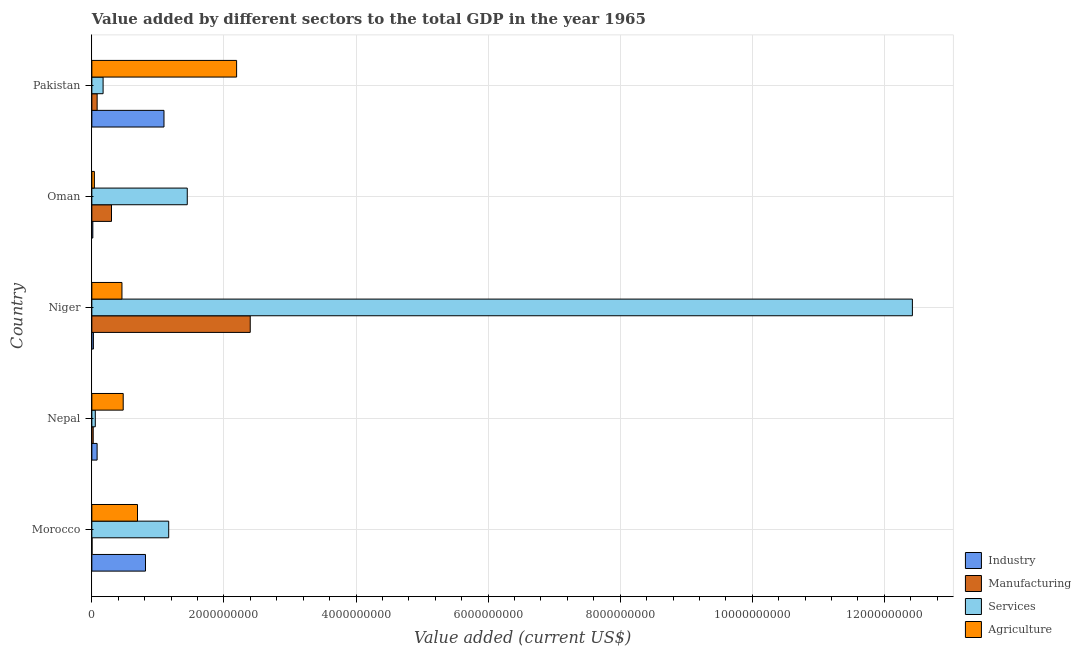How many different coloured bars are there?
Keep it short and to the point. 4. How many groups of bars are there?
Offer a terse response. 5. Are the number of bars per tick equal to the number of legend labels?
Ensure brevity in your answer.  Yes. How many bars are there on the 2nd tick from the top?
Provide a succinct answer. 4. How many bars are there on the 1st tick from the bottom?
Your answer should be very brief. 4. What is the label of the 3rd group of bars from the top?
Provide a succinct answer. Niger. In how many cases, is the number of bars for a given country not equal to the number of legend labels?
Your answer should be compact. 0. What is the value added by agricultural sector in Nepal?
Ensure brevity in your answer.  4.75e+08. Across all countries, what is the maximum value added by industrial sector?
Make the answer very short. 1.09e+09. Across all countries, what is the minimum value added by industrial sector?
Your answer should be compact. 1.48e+07. In which country was the value added by services sector maximum?
Keep it short and to the point. Niger. In which country was the value added by industrial sector minimum?
Make the answer very short. Oman. What is the total value added by services sector in the graph?
Your answer should be compact. 1.53e+1. What is the difference between the value added by services sector in Niger and that in Pakistan?
Ensure brevity in your answer.  1.23e+1. What is the difference between the value added by industrial sector in Morocco and the value added by agricultural sector in Oman?
Provide a short and direct response. 7.74e+08. What is the average value added by agricultural sector per country?
Provide a short and direct response. 7.70e+08. What is the difference between the value added by manufacturing sector and value added by services sector in Pakistan?
Offer a terse response. -9.02e+07. In how many countries, is the value added by industrial sector greater than 7200000000 US$?
Your answer should be very brief. 0. What is the ratio of the value added by industrial sector in Morocco to that in Nepal?
Offer a very short reply. 10.18. Is the value added by manufacturing sector in Oman less than that in Pakistan?
Your answer should be very brief. No. Is the difference between the value added by industrial sector in Nepal and Niger greater than the difference between the value added by manufacturing sector in Nepal and Niger?
Ensure brevity in your answer.  Yes. What is the difference between the highest and the second highest value added by manufacturing sector?
Your answer should be very brief. 2.10e+09. What is the difference between the highest and the lowest value added by services sector?
Make the answer very short. 1.24e+1. In how many countries, is the value added by agricultural sector greater than the average value added by agricultural sector taken over all countries?
Your answer should be very brief. 1. Is it the case that in every country, the sum of the value added by manufacturing sector and value added by industrial sector is greater than the sum of value added by services sector and value added by agricultural sector?
Offer a very short reply. No. What does the 4th bar from the top in Nepal represents?
Your answer should be very brief. Industry. What does the 4th bar from the bottom in Nepal represents?
Provide a succinct answer. Agriculture. How many bars are there?
Make the answer very short. 20. How many countries are there in the graph?
Provide a short and direct response. 5. What is the difference between two consecutive major ticks on the X-axis?
Provide a short and direct response. 2.00e+09. Are the values on the major ticks of X-axis written in scientific E-notation?
Make the answer very short. No. Does the graph contain grids?
Offer a terse response. Yes. How are the legend labels stacked?
Provide a short and direct response. Vertical. What is the title of the graph?
Offer a terse response. Value added by different sectors to the total GDP in the year 1965. Does "Interest Payments" appear as one of the legend labels in the graph?
Give a very brief answer. No. What is the label or title of the X-axis?
Give a very brief answer. Value added (current US$). What is the Value added (current US$) of Industry in Morocco?
Provide a short and direct response. 8.12e+08. What is the Value added (current US$) of Manufacturing in Morocco?
Ensure brevity in your answer.  3.06e+06. What is the Value added (current US$) in Services in Morocco?
Your answer should be very brief. 1.16e+09. What is the Value added (current US$) of Agriculture in Morocco?
Your answer should be very brief. 6.91e+08. What is the Value added (current US$) in Industry in Nepal?
Keep it short and to the point. 7.98e+07. What is the Value added (current US$) in Manufacturing in Nepal?
Give a very brief answer. 2.06e+07. What is the Value added (current US$) of Services in Nepal?
Your answer should be very brief. 5.22e+07. What is the Value added (current US$) of Agriculture in Nepal?
Provide a short and direct response. 4.75e+08. What is the Value added (current US$) of Industry in Niger?
Offer a terse response. 2.34e+07. What is the Value added (current US$) of Manufacturing in Niger?
Your response must be concise. 2.40e+09. What is the Value added (current US$) of Services in Niger?
Provide a short and direct response. 1.24e+1. What is the Value added (current US$) in Agriculture in Niger?
Ensure brevity in your answer.  4.56e+08. What is the Value added (current US$) of Industry in Oman?
Your answer should be very brief. 1.48e+07. What is the Value added (current US$) in Manufacturing in Oman?
Your answer should be very brief. 2.98e+08. What is the Value added (current US$) in Services in Oman?
Your response must be concise. 1.44e+09. What is the Value added (current US$) of Agriculture in Oman?
Your answer should be compact. 3.84e+07. What is the Value added (current US$) in Industry in Pakistan?
Offer a very short reply. 1.09e+09. What is the Value added (current US$) in Manufacturing in Pakistan?
Your answer should be very brief. 8.01e+07. What is the Value added (current US$) of Services in Pakistan?
Your answer should be compact. 1.70e+08. What is the Value added (current US$) in Agriculture in Pakistan?
Keep it short and to the point. 2.19e+09. Across all countries, what is the maximum Value added (current US$) of Industry?
Ensure brevity in your answer.  1.09e+09. Across all countries, what is the maximum Value added (current US$) of Manufacturing?
Make the answer very short. 2.40e+09. Across all countries, what is the maximum Value added (current US$) of Services?
Ensure brevity in your answer.  1.24e+1. Across all countries, what is the maximum Value added (current US$) in Agriculture?
Your response must be concise. 2.19e+09. Across all countries, what is the minimum Value added (current US$) in Industry?
Offer a terse response. 1.48e+07. Across all countries, what is the minimum Value added (current US$) of Manufacturing?
Give a very brief answer. 3.06e+06. Across all countries, what is the minimum Value added (current US$) of Services?
Give a very brief answer. 5.22e+07. Across all countries, what is the minimum Value added (current US$) of Agriculture?
Your answer should be very brief. 3.84e+07. What is the total Value added (current US$) in Industry in the graph?
Your answer should be compact. 2.02e+09. What is the total Value added (current US$) in Manufacturing in the graph?
Your response must be concise. 2.80e+09. What is the total Value added (current US$) in Services in the graph?
Ensure brevity in your answer.  1.53e+1. What is the total Value added (current US$) of Agriculture in the graph?
Provide a succinct answer. 3.85e+09. What is the difference between the Value added (current US$) of Industry in Morocco and that in Nepal?
Offer a very short reply. 7.32e+08. What is the difference between the Value added (current US$) in Manufacturing in Morocco and that in Nepal?
Keep it short and to the point. -1.76e+07. What is the difference between the Value added (current US$) of Services in Morocco and that in Nepal?
Your answer should be compact. 1.11e+09. What is the difference between the Value added (current US$) of Agriculture in Morocco and that in Nepal?
Make the answer very short. 2.16e+08. What is the difference between the Value added (current US$) in Industry in Morocco and that in Niger?
Your answer should be very brief. 7.89e+08. What is the difference between the Value added (current US$) of Manufacturing in Morocco and that in Niger?
Make the answer very short. -2.40e+09. What is the difference between the Value added (current US$) in Services in Morocco and that in Niger?
Give a very brief answer. -1.13e+1. What is the difference between the Value added (current US$) of Agriculture in Morocco and that in Niger?
Your answer should be very brief. 2.35e+08. What is the difference between the Value added (current US$) in Industry in Morocco and that in Oman?
Provide a succinct answer. 7.97e+08. What is the difference between the Value added (current US$) of Manufacturing in Morocco and that in Oman?
Provide a short and direct response. -2.95e+08. What is the difference between the Value added (current US$) in Services in Morocco and that in Oman?
Your answer should be compact. -2.81e+08. What is the difference between the Value added (current US$) of Agriculture in Morocco and that in Oman?
Offer a very short reply. 6.53e+08. What is the difference between the Value added (current US$) in Industry in Morocco and that in Pakistan?
Keep it short and to the point. -2.80e+08. What is the difference between the Value added (current US$) in Manufacturing in Morocco and that in Pakistan?
Give a very brief answer. -7.71e+07. What is the difference between the Value added (current US$) of Services in Morocco and that in Pakistan?
Ensure brevity in your answer.  9.93e+08. What is the difference between the Value added (current US$) in Agriculture in Morocco and that in Pakistan?
Offer a terse response. -1.50e+09. What is the difference between the Value added (current US$) of Industry in Nepal and that in Niger?
Your response must be concise. 5.64e+07. What is the difference between the Value added (current US$) of Manufacturing in Nepal and that in Niger?
Provide a short and direct response. -2.38e+09. What is the difference between the Value added (current US$) in Services in Nepal and that in Niger?
Your answer should be compact. -1.24e+1. What is the difference between the Value added (current US$) of Agriculture in Nepal and that in Niger?
Provide a succinct answer. 1.90e+07. What is the difference between the Value added (current US$) of Industry in Nepal and that in Oman?
Make the answer very short. 6.50e+07. What is the difference between the Value added (current US$) of Manufacturing in Nepal and that in Oman?
Ensure brevity in your answer.  -2.77e+08. What is the difference between the Value added (current US$) in Services in Nepal and that in Oman?
Your answer should be compact. -1.39e+09. What is the difference between the Value added (current US$) of Agriculture in Nepal and that in Oman?
Make the answer very short. 4.37e+08. What is the difference between the Value added (current US$) of Industry in Nepal and that in Pakistan?
Offer a terse response. -1.01e+09. What is the difference between the Value added (current US$) of Manufacturing in Nepal and that in Pakistan?
Provide a succinct answer. -5.95e+07. What is the difference between the Value added (current US$) in Services in Nepal and that in Pakistan?
Your answer should be very brief. -1.18e+08. What is the difference between the Value added (current US$) of Agriculture in Nepal and that in Pakistan?
Provide a short and direct response. -1.72e+09. What is the difference between the Value added (current US$) of Industry in Niger and that in Oman?
Ensure brevity in your answer.  8.54e+06. What is the difference between the Value added (current US$) in Manufacturing in Niger and that in Oman?
Give a very brief answer. 2.10e+09. What is the difference between the Value added (current US$) of Services in Niger and that in Oman?
Make the answer very short. 1.10e+1. What is the difference between the Value added (current US$) of Agriculture in Niger and that in Oman?
Offer a very short reply. 4.18e+08. What is the difference between the Value added (current US$) of Industry in Niger and that in Pakistan?
Provide a short and direct response. -1.07e+09. What is the difference between the Value added (current US$) of Manufacturing in Niger and that in Pakistan?
Your response must be concise. 2.32e+09. What is the difference between the Value added (current US$) of Services in Niger and that in Pakistan?
Your answer should be very brief. 1.23e+1. What is the difference between the Value added (current US$) in Agriculture in Niger and that in Pakistan?
Make the answer very short. -1.74e+09. What is the difference between the Value added (current US$) of Industry in Oman and that in Pakistan?
Keep it short and to the point. -1.08e+09. What is the difference between the Value added (current US$) in Manufacturing in Oman and that in Pakistan?
Keep it short and to the point. 2.18e+08. What is the difference between the Value added (current US$) of Services in Oman and that in Pakistan?
Your response must be concise. 1.27e+09. What is the difference between the Value added (current US$) in Agriculture in Oman and that in Pakistan?
Offer a terse response. -2.15e+09. What is the difference between the Value added (current US$) of Industry in Morocco and the Value added (current US$) of Manufacturing in Nepal?
Provide a short and direct response. 7.92e+08. What is the difference between the Value added (current US$) in Industry in Morocco and the Value added (current US$) in Services in Nepal?
Give a very brief answer. 7.60e+08. What is the difference between the Value added (current US$) of Industry in Morocco and the Value added (current US$) of Agriculture in Nepal?
Your answer should be very brief. 3.37e+08. What is the difference between the Value added (current US$) of Manufacturing in Morocco and the Value added (current US$) of Services in Nepal?
Your response must be concise. -4.92e+07. What is the difference between the Value added (current US$) in Manufacturing in Morocco and the Value added (current US$) in Agriculture in Nepal?
Offer a terse response. -4.72e+08. What is the difference between the Value added (current US$) of Services in Morocco and the Value added (current US$) of Agriculture in Nepal?
Offer a very short reply. 6.89e+08. What is the difference between the Value added (current US$) of Industry in Morocco and the Value added (current US$) of Manufacturing in Niger?
Offer a very short reply. -1.59e+09. What is the difference between the Value added (current US$) in Industry in Morocco and the Value added (current US$) in Services in Niger?
Keep it short and to the point. -1.16e+1. What is the difference between the Value added (current US$) of Industry in Morocco and the Value added (current US$) of Agriculture in Niger?
Ensure brevity in your answer.  3.56e+08. What is the difference between the Value added (current US$) in Manufacturing in Morocco and the Value added (current US$) in Services in Niger?
Your response must be concise. -1.24e+1. What is the difference between the Value added (current US$) in Manufacturing in Morocco and the Value added (current US$) in Agriculture in Niger?
Offer a very short reply. -4.53e+08. What is the difference between the Value added (current US$) in Services in Morocco and the Value added (current US$) in Agriculture in Niger?
Ensure brevity in your answer.  7.08e+08. What is the difference between the Value added (current US$) of Industry in Morocco and the Value added (current US$) of Manufacturing in Oman?
Offer a very short reply. 5.14e+08. What is the difference between the Value added (current US$) in Industry in Morocco and the Value added (current US$) in Services in Oman?
Keep it short and to the point. -6.33e+08. What is the difference between the Value added (current US$) in Industry in Morocco and the Value added (current US$) in Agriculture in Oman?
Your answer should be compact. 7.74e+08. What is the difference between the Value added (current US$) in Manufacturing in Morocco and the Value added (current US$) in Services in Oman?
Ensure brevity in your answer.  -1.44e+09. What is the difference between the Value added (current US$) of Manufacturing in Morocco and the Value added (current US$) of Agriculture in Oman?
Provide a succinct answer. -3.53e+07. What is the difference between the Value added (current US$) of Services in Morocco and the Value added (current US$) of Agriculture in Oman?
Give a very brief answer. 1.13e+09. What is the difference between the Value added (current US$) in Industry in Morocco and the Value added (current US$) in Manufacturing in Pakistan?
Your answer should be very brief. 7.32e+08. What is the difference between the Value added (current US$) in Industry in Morocco and the Value added (current US$) in Services in Pakistan?
Your answer should be compact. 6.42e+08. What is the difference between the Value added (current US$) of Industry in Morocco and the Value added (current US$) of Agriculture in Pakistan?
Provide a succinct answer. -1.38e+09. What is the difference between the Value added (current US$) of Manufacturing in Morocco and the Value added (current US$) of Services in Pakistan?
Your answer should be compact. -1.67e+08. What is the difference between the Value added (current US$) in Manufacturing in Morocco and the Value added (current US$) in Agriculture in Pakistan?
Offer a very short reply. -2.19e+09. What is the difference between the Value added (current US$) of Services in Morocco and the Value added (current US$) of Agriculture in Pakistan?
Your answer should be very brief. -1.03e+09. What is the difference between the Value added (current US$) of Industry in Nepal and the Value added (current US$) of Manufacturing in Niger?
Keep it short and to the point. -2.32e+09. What is the difference between the Value added (current US$) in Industry in Nepal and the Value added (current US$) in Services in Niger?
Your response must be concise. -1.23e+1. What is the difference between the Value added (current US$) in Industry in Nepal and the Value added (current US$) in Agriculture in Niger?
Your answer should be very brief. -3.76e+08. What is the difference between the Value added (current US$) of Manufacturing in Nepal and the Value added (current US$) of Services in Niger?
Provide a short and direct response. -1.24e+1. What is the difference between the Value added (current US$) of Manufacturing in Nepal and the Value added (current US$) of Agriculture in Niger?
Give a very brief answer. -4.35e+08. What is the difference between the Value added (current US$) of Services in Nepal and the Value added (current US$) of Agriculture in Niger?
Keep it short and to the point. -4.04e+08. What is the difference between the Value added (current US$) in Industry in Nepal and the Value added (current US$) in Manufacturing in Oman?
Your response must be concise. -2.18e+08. What is the difference between the Value added (current US$) in Industry in Nepal and the Value added (current US$) in Services in Oman?
Ensure brevity in your answer.  -1.37e+09. What is the difference between the Value added (current US$) of Industry in Nepal and the Value added (current US$) of Agriculture in Oman?
Provide a short and direct response. 4.14e+07. What is the difference between the Value added (current US$) of Manufacturing in Nepal and the Value added (current US$) of Services in Oman?
Your answer should be compact. -1.42e+09. What is the difference between the Value added (current US$) in Manufacturing in Nepal and the Value added (current US$) in Agriculture in Oman?
Give a very brief answer. -1.77e+07. What is the difference between the Value added (current US$) of Services in Nepal and the Value added (current US$) of Agriculture in Oman?
Offer a very short reply. 1.39e+07. What is the difference between the Value added (current US$) of Industry in Nepal and the Value added (current US$) of Manufacturing in Pakistan?
Keep it short and to the point. -3.26e+05. What is the difference between the Value added (current US$) in Industry in Nepal and the Value added (current US$) in Services in Pakistan?
Make the answer very short. -9.06e+07. What is the difference between the Value added (current US$) in Industry in Nepal and the Value added (current US$) in Agriculture in Pakistan?
Ensure brevity in your answer.  -2.11e+09. What is the difference between the Value added (current US$) in Manufacturing in Nepal and the Value added (current US$) in Services in Pakistan?
Ensure brevity in your answer.  -1.50e+08. What is the difference between the Value added (current US$) of Manufacturing in Nepal and the Value added (current US$) of Agriculture in Pakistan?
Your response must be concise. -2.17e+09. What is the difference between the Value added (current US$) of Services in Nepal and the Value added (current US$) of Agriculture in Pakistan?
Offer a terse response. -2.14e+09. What is the difference between the Value added (current US$) in Industry in Niger and the Value added (current US$) in Manufacturing in Oman?
Offer a very short reply. -2.74e+08. What is the difference between the Value added (current US$) in Industry in Niger and the Value added (current US$) in Services in Oman?
Offer a terse response. -1.42e+09. What is the difference between the Value added (current US$) of Industry in Niger and the Value added (current US$) of Agriculture in Oman?
Keep it short and to the point. -1.50e+07. What is the difference between the Value added (current US$) in Manufacturing in Niger and the Value added (current US$) in Services in Oman?
Make the answer very short. 9.53e+08. What is the difference between the Value added (current US$) of Manufacturing in Niger and the Value added (current US$) of Agriculture in Oman?
Offer a terse response. 2.36e+09. What is the difference between the Value added (current US$) of Services in Niger and the Value added (current US$) of Agriculture in Oman?
Your response must be concise. 1.24e+1. What is the difference between the Value added (current US$) of Industry in Niger and the Value added (current US$) of Manufacturing in Pakistan?
Keep it short and to the point. -5.67e+07. What is the difference between the Value added (current US$) of Industry in Niger and the Value added (current US$) of Services in Pakistan?
Your response must be concise. -1.47e+08. What is the difference between the Value added (current US$) of Industry in Niger and the Value added (current US$) of Agriculture in Pakistan?
Offer a very short reply. -2.17e+09. What is the difference between the Value added (current US$) of Manufacturing in Niger and the Value added (current US$) of Services in Pakistan?
Provide a succinct answer. 2.23e+09. What is the difference between the Value added (current US$) of Manufacturing in Niger and the Value added (current US$) of Agriculture in Pakistan?
Give a very brief answer. 2.06e+08. What is the difference between the Value added (current US$) in Services in Niger and the Value added (current US$) in Agriculture in Pakistan?
Provide a short and direct response. 1.02e+1. What is the difference between the Value added (current US$) in Industry in Oman and the Value added (current US$) in Manufacturing in Pakistan?
Provide a short and direct response. -6.53e+07. What is the difference between the Value added (current US$) of Industry in Oman and the Value added (current US$) of Services in Pakistan?
Offer a terse response. -1.56e+08. What is the difference between the Value added (current US$) of Industry in Oman and the Value added (current US$) of Agriculture in Pakistan?
Ensure brevity in your answer.  -2.18e+09. What is the difference between the Value added (current US$) in Manufacturing in Oman and the Value added (current US$) in Services in Pakistan?
Provide a succinct answer. 1.27e+08. What is the difference between the Value added (current US$) of Manufacturing in Oman and the Value added (current US$) of Agriculture in Pakistan?
Your answer should be compact. -1.89e+09. What is the difference between the Value added (current US$) of Services in Oman and the Value added (current US$) of Agriculture in Pakistan?
Your answer should be compact. -7.47e+08. What is the average Value added (current US$) of Industry per country?
Offer a very short reply. 4.05e+08. What is the average Value added (current US$) in Manufacturing per country?
Offer a terse response. 5.60e+08. What is the average Value added (current US$) of Services per country?
Give a very brief answer. 3.05e+09. What is the average Value added (current US$) of Agriculture per country?
Keep it short and to the point. 7.70e+08. What is the difference between the Value added (current US$) in Industry and Value added (current US$) in Manufacturing in Morocco?
Keep it short and to the point. 8.09e+08. What is the difference between the Value added (current US$) in Industry and Value added (current US$) in Services in Morocco?
Make the answer very short. -3.52e+08. What is the difference between the Value added (current US$) in Industry and Value added (current US$) in Agriculture in Morocco?
Make the answer very short. 1.21e+08. What is the difference between the Value added (current US$) in Manufacturing and Value added (current US$) in Services in Morocco?
Ensure brevity in your answer.  -1.16e+09. What is the difference between the Value added (current US$) in Manufacturing and Value added (current US$) in Agriculture in Morocco?
Make the answer very short. -6.88e+08. What is the difference between the Value added (current US$) of Services and Value added (current US$) of Agriculture in Morocco?
Make the answer very short. 4.72e+08. What is the difference between the Value added (current US$) in Industry and Value added (current US$) in Manufacturing in Nepal?
Give a very brief answer. 5.92e+07. What is the difference between the Value added (current US$) in Industry and Value added (current US$) in Services in Nepal?
Ensure brevity in your answer.  2.76e+07. What is the difference between the Value added (current US$) of Industry and Value added (current US$) of Agriculture in Nepal?
Offer a very short reply. -3.95e+08. What is the difference between the Value added (current US$) of Manufacturing and Value added (current US$) of Services in Nepal?
Provide a short and direct response. -3.16e+07. What is the difference between the Value added (current US$) in Manufacturing and Value added (current US$) in Agriculture in Nepal?
Keep it short and to the point. -4.54e+08. What is the difference between the Value added (current US$) of Services and Value added (current US$) of Agriculture in Nepal?
Offer a terse response. -4.23e+08. What is the difference between the Value added (current US$) of Industry and Value added (current US$) of Manufacturing in Niger?
Provide a succinct answer. -2.37e+09. What is the difference between the Value added (current US$) of Industry and Value added (current US$) of Services in Niger?
Offer a very short reply. -1.24e+1. What is the difference between the Value added (current US$) of Industry and Value added (current US$) of Agriculture in Niger?
Keep it short and to the point. -4.33e+08. What is the difference between the Value added (current US$) of Manufacturing and Value added (current US$) of Services in Niger?
Keep it short and to the point. -1.00e+1. What is the difference between the Value added (current US$) in Manufacturing and Value added (current US$) in Agriculture in Niger?
Provide a succinct answer. 1.94e+09. What is the difference between the Value added (current US$) in Services and Value added (current US$) in Agriculture in Niger?
Ensure brevity in your answer.  1.20e+1. What is the difference between the Value added (current US$) in Industry and Value added (current US$) in Manufacturing in Oman?
Offer a terse response. -2.83e+08. What is the difference between the Value added (current US$) of Industry and Value added (current US$) of Services in Oman?
Keep it short and to the point. -1.43e+09. What is the difference between the Value added (current US$) of Industry and Value added (current US$) of Agriculture in Oman?
Make the answer very short. -2.35e+07. What is the difference between the Value added (current US$) in Manufacturing and Value added (current US$) in Services in Oman?
Offer a very short reply. -1.15e+09. What is the difference between the Value added (current US$) in Manufacturing and Value added (current US$) in Agriculture in Oman?
Offer a terse response. 2.59e+08. What is the difference between the Value added (current US$) of Services and Value added (current US$) of Agriculture in Oman?
Keep it short and to the point. 1.41e+09. What is the difference between the Value added (current US$) in Industry and Value added (current US$) in Manufacturing in Pakistan?
Offer a very short reply. 1.01e+09. What is the difference between the Value added (current US$) of Industry and Value added (current US$) of Services in Pakistan?
Offer a terse response. 9.22e+08. What is the difference between the Value added (current US$) of Industry and Value added (current US$) of Agriculture in Pakistan?
Provide a succinct answer. -1.10e+09. What is the difference between the Value added (current US$) in Manufacturing and Value added (current US$) in Services in Pakistan?
Offer a terse response. -9.02e+07. What is the difference between the Value added (current US$) of Manufacturing and Value added (current US$) of Agriculture in Pakistan?
Your answer should be very brief. -2.11e+09. What is the difference between the Value added (current US$) of Services and Value added (current US$) of Agriculture in Pakistan?
Offer a very short reply. -2.02e+09. What is the ratio of the Value added (current US$) of Industry in Morocco to that in Nepal?
Offer a terse response. 10.18. What is the ratio of the Value added (current US$) of Manufacturing in Morocco to that in Nepal?
Give a very brief answer. 0.15. What is the ratio of the Value added (current US$) of Services in Morocco to that in Nepal?
Your answer should be very brief. 22.28. What is the ratio of the Value added (current US$) of Agriculture in Morocco to that in Nepal?
Ensure brevity in your answer.  1.46. What is the ratio of the Value added (current US$) in Industry in Morocco to that in Niger?
Give a very brief answer. 34.74. What is the ratio of the Value added (current US$) of Manufacturing in Morocco to that in Niger?
Offer a very short reply. 0. What is the ratio of the Value added (current US$) of Services in Morocco to that in Niger?
Offer a very short reply. 0.09. What is the ratio of the Value added (current US$) of Agriculture in Morocco to that in Niger?
Give a very brief answer. 1.52. What is the ratio of the Value added (current US$) of Industry in Morocco to that in Oman?
Your answer should be very brief. 54.73. What is the ratio of the Value added (current US$) in Manufacturing in Morocco to that in Oman?
Offer a very short reply. 0.01. What is the ratio of the Value added (current US$) in Services in Morocco to that in Oman?
Provide a short and direct response. 0.81. What is the ratio of the Value added (current US$) in Agriculture in Morocco to that in Oman?
Make the answer very short. 18.02. What is the ratio of the Value added (current US$) of Industry in Morocco to that in Pakistan?
Keep it short and to the point. 0.74. What is the ratio of the Value added (current US$) in Manufacturing in Morocco to that in Pakistan?
Your answer should be compact. 0.04. What is the ratio of the Value added (current US$) of Services in Morocco to that in Pakistan?
Provide a succinct answer. 6.83. What is the ratio of the Value added (current US$) in Agriculture in Morocco to that in Pakistan?
Keep it short and to the point. 0.32. What is the ratio of the Value added (current US$) in Industry in Nepal to that in Niger?
Provide a succinct answer. 3.41. What is the ratio of the Value added (current US$) of Manufacturing in Nepal to that in Niger?
Provide a short and direct response. 0.01. What is the ratio of the Value added (current US$) in Services in Nepal to that in Niger?
Provide a succinct answer. 0. What is the ratio of the Value added (current US$) of Agriculture in Nepal to that in Niger?
Your answer should be very brief. 1.04. What is the ratio of the Value added (current US$) of Industry in Nepal to that in Oman?
Provide a succinct answer. 5.38. What is the ratio of the Value added (current US$) of Manufacturing in Nepal to that in Oman?
Ensure brevity in your answer.  0.07. What is the ratio of the Value added (current US$) of Services in Nepal to that in Oman?
Make the answer very short. 0.04. What is the ratio of the Value added (current US$) of Agriculture in Nepal to that in Oman?
Offer a terse response. 12.38. What is the ratio of the Value added (current US$) of Industry in Nepal to that in Pakistan?
Your answer should be compact. 0.07. What is the ratio of the Value added (current US$) of Manufacturing in Nepal to that in Pakistan?
Ensure brevity in your answer.  0.26. What is the ratio of the Value added (current US$) in Services in Nepal to that in Pakistan?
Make the answer very short. 0.31. What is the ratio of the Value added (current US$) in Agriculture in Nepal to that in Pakistan?
Your answer should be very brief. 0.22. What is the ratio of the Value added (current US$) of Industry in Niger to that in Oman?
Your answer should be compact. 1.58. What is the ratio of the Value added (current US$) in Manufacturing in Niger to that in Oman?
Ensure brevity in your answer.  8.06. What is the ratio of the Value added (current US$) of Services in Niger to that in Oman?
Your answer should be compact. 8.6. What is the ratio of the Value added (current US$) of Agriculture in Niger to that in Oman?
Give a very brief answer. 11.88. What is the ratio of the Value added (current US$) of Industry in Niger to that in Pakistan?
Your response must be concise. 0.02. What is the ratio of the Value added (current US$) of Manufacturing in Niger to that in Pakistan?
Offer a terse response. 29.93. What is the ratio of the Value added (current US$) of Services in Niger to that in Pakistan?
Provide a short and direct response. 72.93. What is the ratio of the Value added (current US$) of Agriculture in Niger to that in Pakistan?
Ensure brevity in your answer.  0.21. What is the ratio of the Value added (current US$) of Industry in Oman to that in Pakistan?
Your answer should be compact. 0.01. What is the ratio of the Value added (current US$) of Manufacturing in Oman to that in Pakistan?
Keep it short and to the point. 3.72. What is the ratio of the Value added (current US$) in Services in Oman to that in Pakistan?
Offer a very short reply. 8.48. What is the ratio of the Value added (current US$) of Agriculture in Oman to that in Pakistan?
Your answer should be compact. 0.02. What is the difference between the highest and the second highest Value added (current US$) in Industry?
Give a very brief answer. 2.80e+08. What is the difference between the highest and the second highest Value added (current US$) in Manufacturing?
Your answer should be compact. 2.10e+09. What is the difference between the highest and the second highest Value added (current US$) in Services?
Give a very brief answer. 1.10e+1. What is the difference between the highest and the second highest Value added (current US$) of Agriculture?
Give a very brief answer. 1.50e+09. What is the difference between the highest and the lowest Value added (current US$) in Industry?
Offer a terse response. 1.08e+09. What is the difference between the highest and the lowest Value added (current US$) of Manufacturing?
Give a very brief answer. 2.40e+09. What is the difference between the highest and the lowest Value added (current US$) of Services?
Provide a succinct answer. 1.24e+1. What is the difference between the highest and the lowest Value added (current US$) of Agriculture?
Your response must be concise. 2.15e+09. 